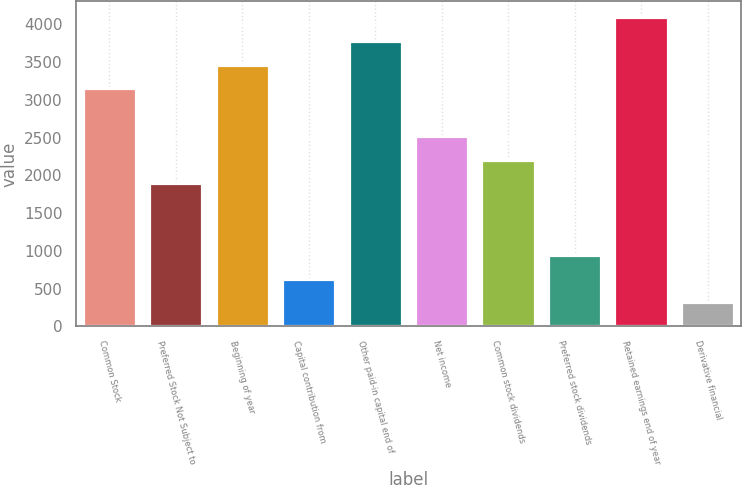<chart> <loc_0><loc_0><loc_500><loc_500><bar_chart><fcel>Common Stock<fcel>Preferred Stock Not Subject to<fcel>Beginning of year<fcel>Capital contribution from<fcel>Other paid-in capital end of<fcel>Net income<fcel>Common stock dividends<fcel>Preferred stock dividends<fcel>Retained earnings end of year<fcel>Derivative financial<nl><fcel>3153<fcel>1892.6<fcel>3468.1<fcel>632.2<fcel>3783.2<fcel>2522.8<fcel>2207.7<fcel>947.3<fcel>4098.3<fcel>317.1<nl></chart> 